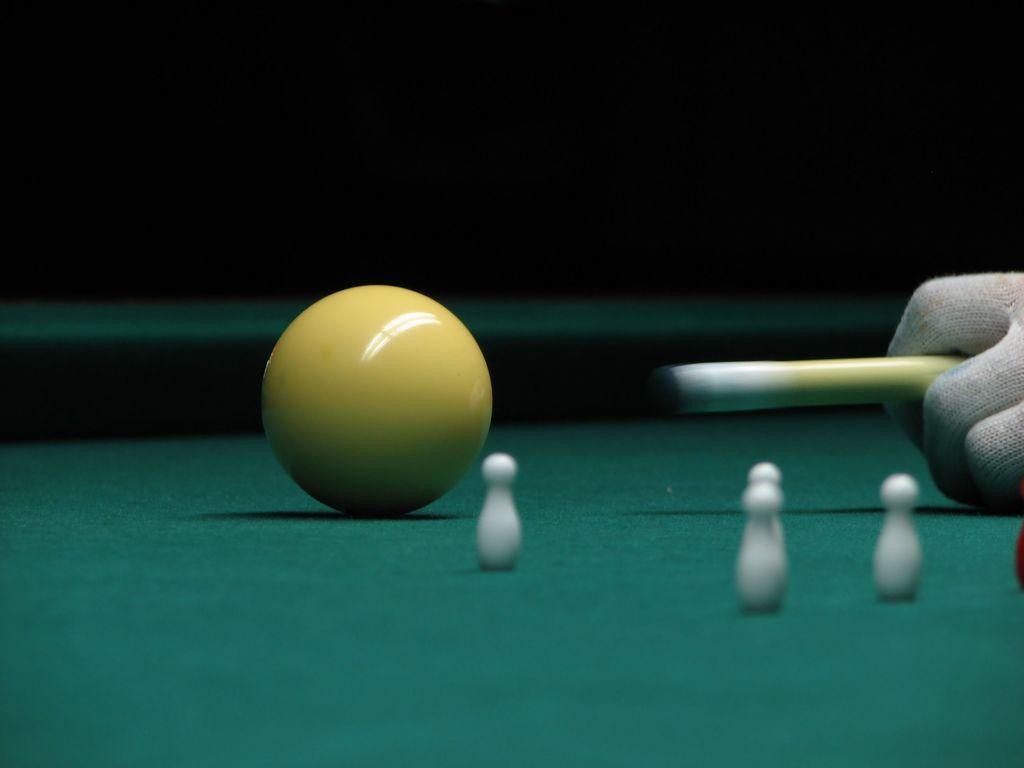What type of game table is present in the image? There is a billiards game table in the image. What is the person in the image attempting to do? The person is trying to hit a ball on the table. What type of muscle is being used by the person to hit the ball in the image? There is no specific muscle mentioned or visible in the image, as it focuses on the billiards game table and the person's action of hitting a ball. 